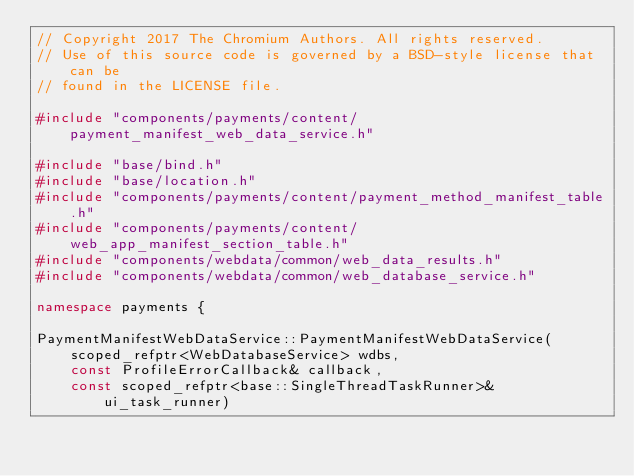<code> <loc_0><loc_0><loc_500><loc_500><_C++_>// Copyright 2017 The Chromium Authors. All rights reserved.
// Use of this source code is governed by a BSD-style license that can be
// found in the LICENSE file.

#include "components/payments/content/payment_manifest_web_data_service.h"

#include "base/bind.h"
#include "base/location.h"
#include "components/payments/content/payment_method_manifest_table.h"
#include "components/payments/content/web_app_manifest_section_table.h"
#include "components/webdata/common/web_data_results.h"
#include "components/webdata/common/web_database_service.h"

namespace payments {

PaymentManifestWebDataService::PaymentManifestWebDataService(
    scoped_refptr<WebDatabaseService> wdbs,
    const ProfileErrorCallback& callback,
    const scoped_refptr<base::SingleThreadTaskRunner>& ui_task_runner)</code> 